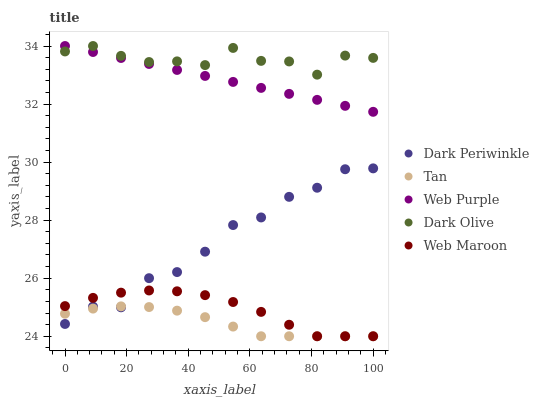Does Tan have the minimum area under the curve?
Answer yes or no. Yes. Does Dark Olive have the maximum area under the curve?
Answer yes or no. Yes. Does Dark Olive have the minimum area under the curve?
Answer yes or no. No. Does Tan have the maximum area under the curve?
Answer yes or no. No. Is Web Purple the smoothest?
Answer yes or no. Yes. Is Dark Periwinkle the roughest?
Answer yes or no. Yes. Is Tan the smoothest?
Answer yes or no. No. Is Tan the roughest?
Answer yes or no. No. Does Tan have the lowest value?
Answer yes or no. Yes. Does Dark Olive have the lowest value?
Answer yes or no. No. Does Dark Olive have the highest value?
Answer yes or no. Yes. Does Tan have the highest value?
Answer yes or no. No. Is Tan less than Web Purple?
Answer yes or no. Yes. Is Web Purple greater than Web Maroon?
Answer yes or no. Yes. Does Dark Olive intersect Web Purple?
Answer yes or no. Yes. Is Dark Olive less than Web Purple?
Answer yes or no. No. Is Dark Olive greater than Web Purple?
Answer yes or no. No. Does Tan intersect Web Purple?
Answer yes or no. No. 